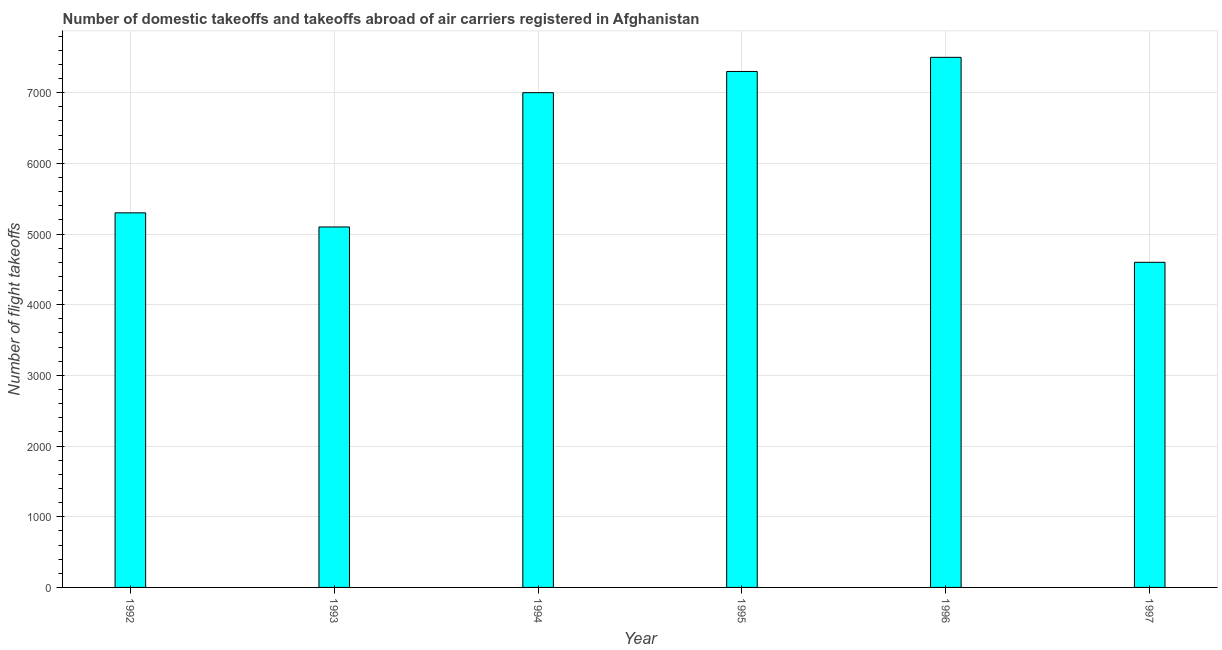Does the graph contain grids?
Give a very brief answer. Yes. What is the title of the graph?
Give a very brief answer. Number of domestic takeoffs and takeoffs abroad of air carriers registered in Afghanistan. What is the label or title of the X-axis?
Your response must be concise. Year. What is the label or title of the Y-axis?
Provide a succinct answer. Number of flight takeoffs. What is the number of flight takeoffs in 1992?
Offer a very short reply. 5300. Across all years, what is the maximum number of flight takeoffs?
Your response must be concise. 7500. Across all years, what is the minimum number of flight takeoffs?
Offer a very short reply. 4600. In which year was the number of flight takeoffs maximum?
Offer a terse response. 1996. In which year was the number of flight takeoffs minimum?
Offer a terse response. 1997. What is the sum of the number of flight takeoffs?
Your answer should be compact. 3.68e+04. What is the difference between the number of flight takeoffs in 1995 and 1996?
Your answer should be very brief. -200. What is the average number of flight takeoffs per year?
Keep it short and to the point. 6133.33. What is the median number of flight takeoffs?
Give a very brief answer. 6150. Do a majority of the years between 1993 and 1994 (inclusive) have number of flight takeoffs greater than 2800 ?
Your answer should be compact. Yes. What is the ratio of the number of flight takeoffs in 1992 to that in 1995?
Offer a terse response. 0.73. Is the difference between the number of flight takeoffs in 1994 and 1996 greater than the difference between any two years?
Your response must be concise. No. What is the difference between the highest and the lowest number of flight takeoffs?
Offer a terse response. 2900. Are all the bars in the graph horizontal?
Keep it short and to the point. No. How many years are there in the graph?
Your response must be concise. 6. What is the difference between two consecutive major ticks on the Y-axis?
Make the answer very short. 1000. What is the Number of flight takeoffs in 1992?
Your answer should be compact. 5300. What is the Number of flight takeoffs of 1993?
Offer a very short reply. 5100. What is the Number of flight takeoffs of 1994?
Offer a terse response. 7000. What is the Number of flight takeoffs in 1995?
Offer a very short reply. 7300. What is the Number of flight takeoffs of 1996?
Keep it short and to the point. 7500. What is the Number of flight takeoffs in 1997?
Keep it short and to the point. 4600. What is the difference between the Number of flight takeoffs in 1992 and 1994?
Make the answer very short. -1700. What is the difference between the Number of flight takeoffs in 1992 and 1995?
Provide a succinct answer. -2000. What is the difference between the Number of flight takeoffs in 1992 and 1996?
Give a very brief answer. -2200. What is the difference between the Number of flight takeoffs in 1992 and 1997?
Give a very brief answer. 700. What is the difference between the Number of flight takeoffs in 1993 and 1994?
Your answer should be compact. -1900. What is the difference between the Number of flight takeoffs in 1993 and 1995?
Your response must be concise. -2200. What is the difference between the Number of flight takeoffs in 1993 and 1996?
Your answer should be compact. -2400. What is the difference between the Number of flight takeoffs in 1994 and 1995?
Provide a succinct answer. -300. What is the difference between the Number of flight takeoffs in 1994 and 1996?
Provide a succinct answer. -500. What is the difference between the Number of flight takeoffs in 1994 and 1997?
Keep it short and to the point. 2400. What is the difference between the Number of flight takeoffs in 1995 and 1996?
Offer a terse response. -200. What is the difference between the Number of flight takeoffs in 1995 and 1997?
Keep it short and to the point. 2700. What is the difference between the Number of flight takeoffs in 1996 and 1997?
Give a very brief answer. 2900. What is the ratio of the Number of flight takeoffs in 1992 to that in 1993?
Your response must be concise. 1.04. What is the ratio of the Number of flight takeoffs in 1992 to that in 1994?
Give a very brief answer. 0.76. What is the ratio of the Number of flight takeoffs in 1992 to that in 1995?
Your answer should be compact. 0.73. What is the ratio of the Number of flight takeoffs in 1992 to that in 1996?
Ensure brevity in your answer.  0.71. What is the ratio of the Number of flight takeoffs in 1992 to that in 1997?
Your answer should be very brief. 1.15. What is the ratio of the Number of flight takeoffs in 1993 to that in 1994?
Your answer should be very brief. 0.73. What is the ratio of the Number of flight takeoffs in 1993 to that in 1995?
Your answer should be very brief. 0.7. What is the ratio of the Number of flight takeoffs in 1993 to that in 1996?
Provide a short and direct response. 0.68. What is the ratio of the Number of flight takeoffs in 1993 to that in 1997?
Ensure brevity in your answer.  1.11. What is the ratio of the Number of flight takeoffs in 1994 to that in 1995?
Provide a succinct answer. 0.96. What is the ratio of the Number of flight takeoffs in 1994 to that in 1996?
Ensure brevity in your answer.  0.93. What is the ratio of the Number of flight takeoffs in 1994 to that in 1997?
Keep it short and to the point. 1.52. What is the ratio of the Number of flight takeoffs in 1995 to that in 1996?
Make the answer very short. 0.97. What is the ratio of the Number of flight takeoffs in 1995 to that in 1997?
Offer a very short reply. 1.59. What is the ratio of the Number of flight takeoffs in 1996 to that in 1997?
Give a very brief answer. 1.63. 